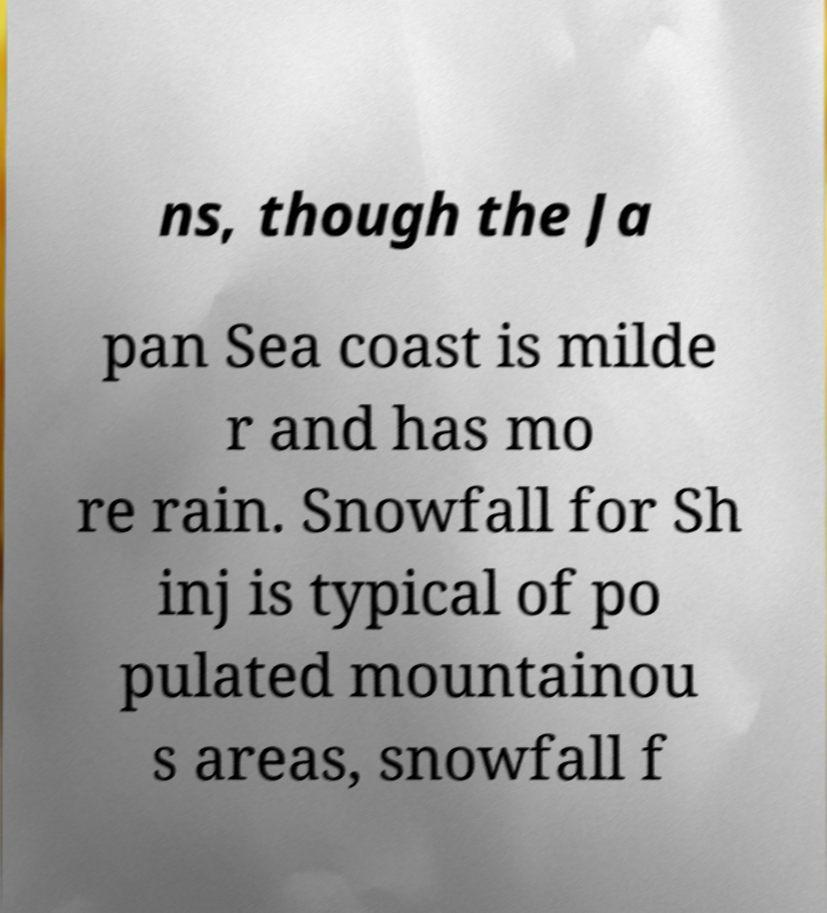For documentation purposes, I need the text within this image transcribed. Could you provide that? ns, though the Ja pan Sea coast is milde r and has mo re rain. Snowfall for Sh inj is typical of po pulated mountainou s areas, snowfall f 